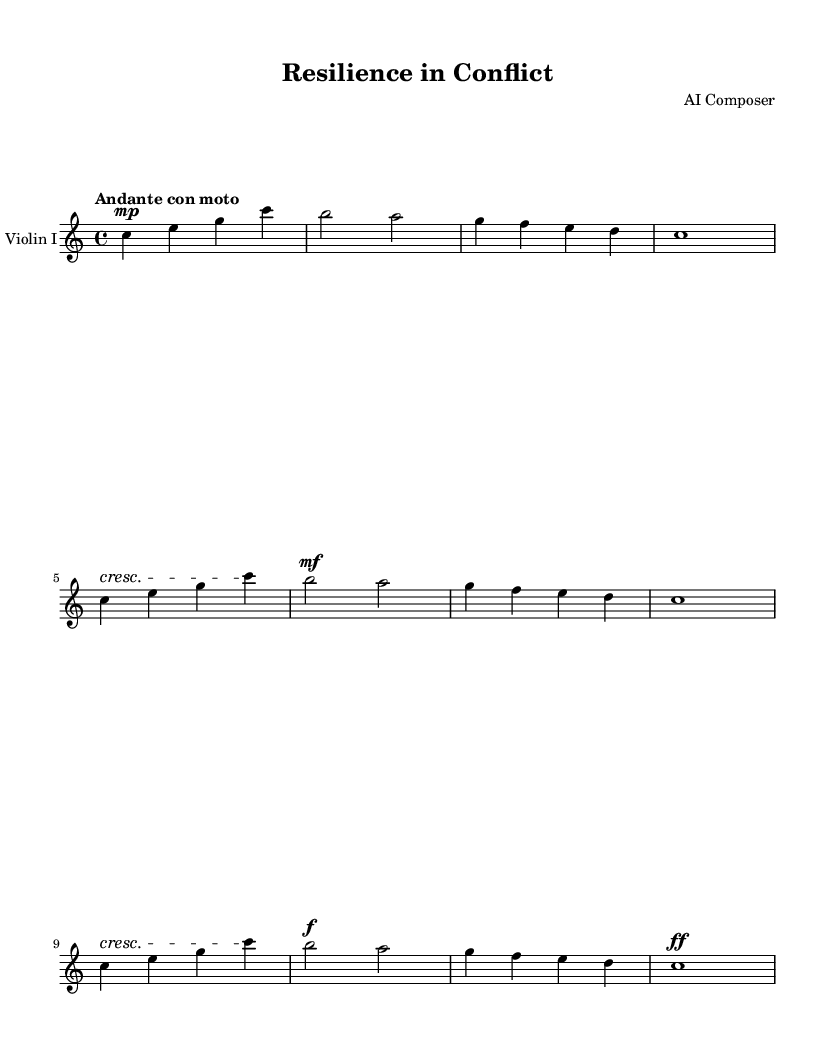What is the key signature of this music? The key signature indicated is C major, which is represented by the absence of sharps or flats.
Answer: C major What is the time signature of the piece? The time signature shown on the sheet music is 4/4, meaning there are four beats in each measure, and a quarter note gets one beat.
Answer: 4/4 What tempo marking is given for this symphony? The tempo marking is "Andante con moto", suggesting a moderately slow pace but with some movement.
Answer: Andante con moto How many measures are there in this excerpt? By counting the measures visually in the provided part for Violin I, there are a total of eight measures shown.
Answer: 8 What is the dynamic marking before the first measure? The dynamic marking seen in the first measure is "mp", which stands for mezzo-piano, indicating a moderately soft volume.
Answer: mp What does the term "cresc" indicate in this context? The term "cresc" stands for "crescendo", which instructs the musicians to gradually increase the volume.
Answer: Crescendo Are there any notes that are marked to be played loudly? Yes, in the last measure, the dynamic marking "ff" indicates that the notes should be played fortissimo, meaning very loud.
Answer: ff 